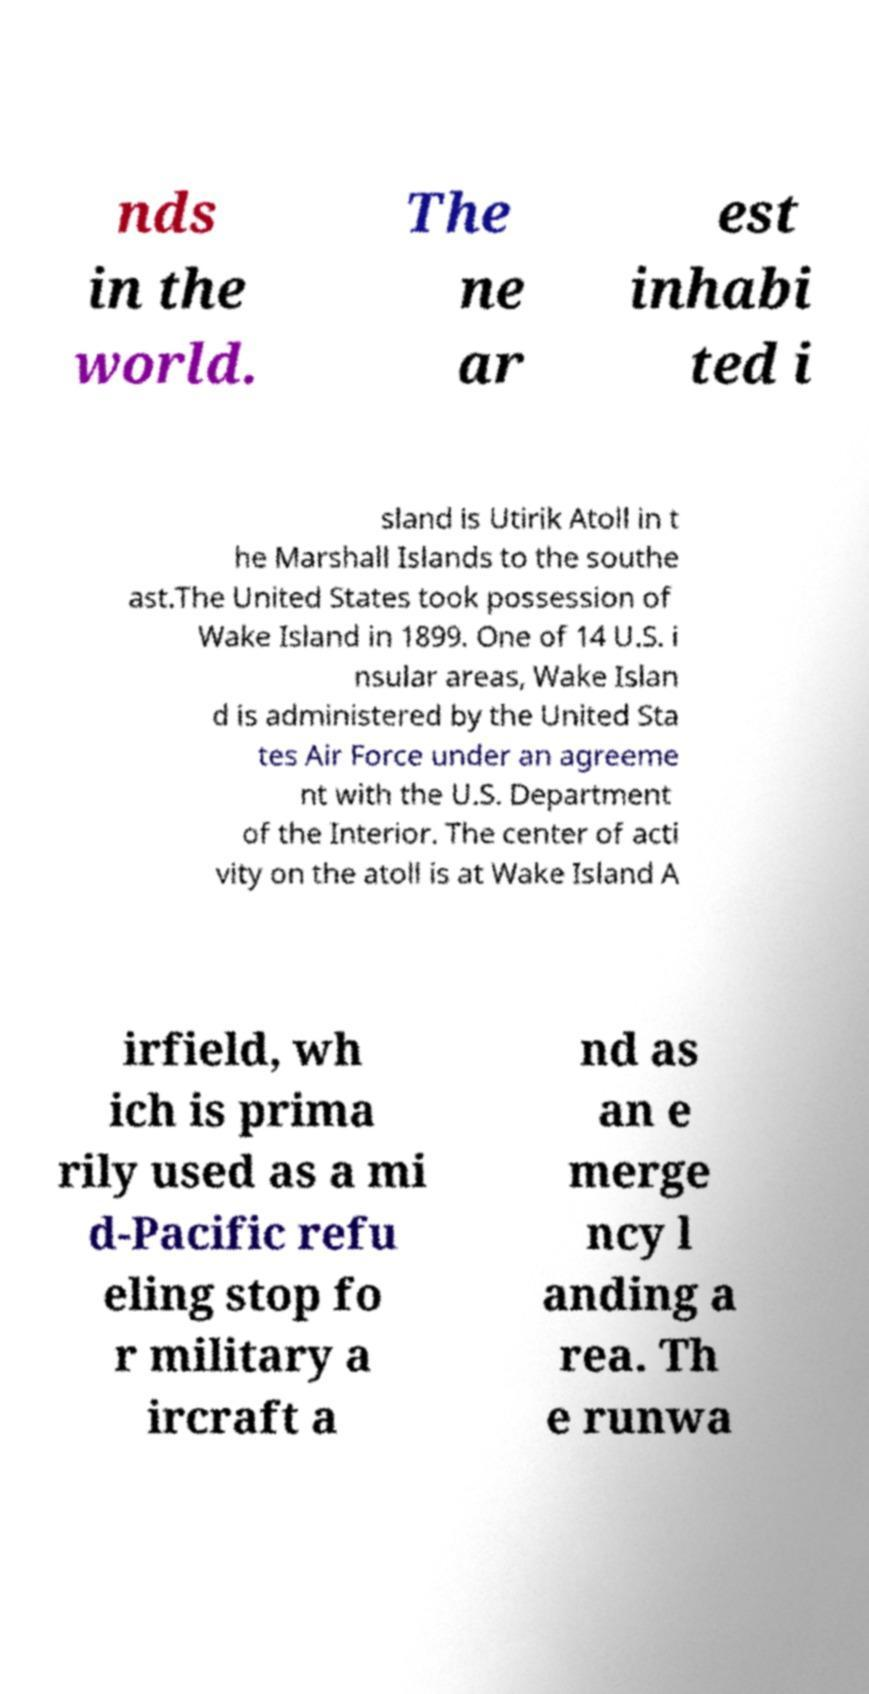There's text embedded in this image that I need extracted. Can you transcribe it verbatim? nds in the world. The ne ar est inhabi ted i sland is Utirik Atoll in t he Marshall Islands to the southe ast.The United States took possession of Wake Island in 1899. One of 14 U.S. i nsular areas, Wake Islan d is administered by the United Sta tes Air Force under an agreeme nt with the U.S. Department of the Interior. The center of acti vity on the atoll is at Wake Island A irfield, wh ich is prima rily used as a mi d-Pacific refu eling stop fo r military a ircraft a nd as an e merge ncy l anding a rea. Th e runwa 